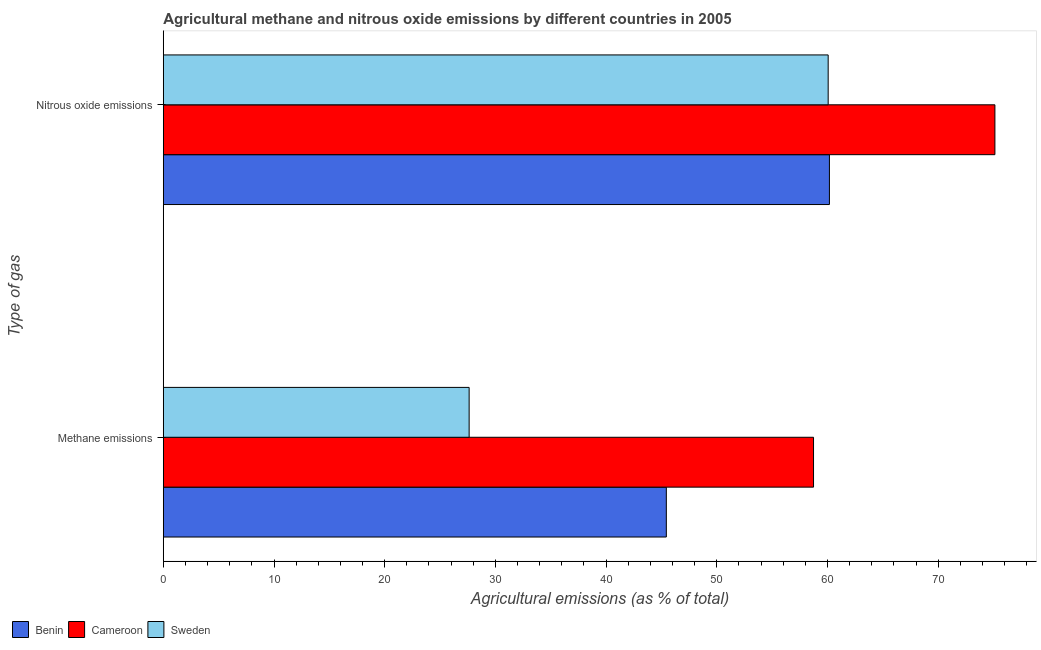How many groups of bars are there?
Provide a succinct answer. 2. How many bars are there on the 2nd tick from the bottom?
Provide a short and direct response. 3. What is the label of the 2nd group of bars from the top?
Offer a terse response. Methane emissions. What is the amount of methane emissions in Sweden?
Provide a succinct answer. 27.63. Across all countries, what is the maximum amount of methane emissions?
Offer a very short reply. 58.74. Across all countries, what is the minimum amount of methane emissions?
Keep it short and to the point. 27.63. In which country was the amount of nitrous oxide emissions maximum?
Make the answer very short. Cameroon. In which country was the amount of methane emissions minimum?
Give a very brief answer. Sweden. What is the total amount of nitrous oxide emissions in the graph?
Keep it short and to the point. 195.37. What is the difference between the amount of nitrous oxide emissions in Cameroon and that in Benin?
Your answer should be compact. 14.95. What is the difference between the amount of nitrous oxide emissions in Benin and the amount of methane emissions in Cameroon?
Give a very brief answer. 1.44. What is the average amount of nitrous oxide emissions per country?
Ensure brevity in your answer.  65.12. What is the difference between the amount of nitrous oxide emissions and amount of methane emissions in Benin?
Provide a succinct answer. 14.73. In how many countries, is the amount of methane emissions greater than 42 %?
Your response must be concise. 2. What is the ratio of the amount of nitrous oxide emissions in Cameroon to that in Benin?
Offer a terse response. 1.25. What does the 3rd bar from the top in Nitrous oxide emissions represents?
Ensure brevity in your answer.  Benin. What does the 1st bar from the bottom in Nitrous oxide emissions represents?
Provide a succinct answer. Benin. Are all the bars in the graph horizontal?
Your response must be concise. Yes. How many countries are there in the graph?
Your answer should be very brief. 3. What is the difference between two consecutive major ticks on the X-axis?
Offer a very short reply. 10. Does the graph contain any zero values?
Provide a succinct answer. No. Where does the legend appear in the graph?
Your answer should be very brief. Bottom left. How many legend labels are there?
Keep it short and to the point. 3. What is the title of the graph?
Your answer should be compact. Agricultural methane and nitrous oxide emissions by different countries in 2005. Does "Timor-Leste" appear as one of the legend labels in the graph?
Provide a succinct answer. No. What is the label or title of the X-axis?
Make the answer very short. Agricultural emissions (as % of total). What is the label or title of the Y-axis?
Ensure brevity in your answer.  Type of gas. What is the Agricultural emissions (as % of total) of Benin in Methane emissions?
Make the answer very short. 45.44. What is the Agricultural emissions (as % of total) in Cameroon in Methane emissions?
Offer a very short reply. 58.74. What is the Agricultural emissions (as % of total) in Sweden in Methane emissions?
Offer a very short reply. 27.63. What is the Agricultural emissions (as % of total) in Benin in Nitrous oxide emissions?
Provide a succinct answer. 60.18. What is the Agricultural emissions (as % of total) of Cameroon in Nitrous oxide emissions?
Provide a succinct answer. 75.13. What is the Agricultural emissions (as % of total) of Sweden in Nitrous oxide emissions?
Your answer should be compact. 60.06. Across all Type of gas, what is the maximum Agricultural emissions (as % of total) in Benin?
Keep it short and to the point. 60.18. Across all Type of gas, what is the maximum Agricultural emissions (as % of total) of Cameroon?
Offer a terse response. 75.13. Across all Type of gas, what is the maximum Agricultural emissions (as % of total) of Sweden?
Make the answer very short. 60.06. Across all Type of gas, what is the minimum Agricultural emissions (as % of total) of Benin?
Your answer should be compact. 45.44. Across all Type of gas, what is the minimum Agricultural emissions (as % of total) in Cameroon?
Make the answer very short. 58.74. Across all Type of gas, what is the minimum Agricultural emissions (as % of total) in Sweden?
Make the answer very short. 27.63. What is the total Agricultural emissions (as % of total) in Benin in the graph?
Give a very brief answer. 105.62. What is the total Agricultural emissions (as % of total) in Cameroon in the graph?
Make the answer very short. 133.87. What is the total Agricultural emissions (as % of total) of Sweden in the graph?
Your answer should be very brief. 87.69. What is the difference between the Agricultural emissions (as % of total) in Benin in Methane emissions and that in Nitrous oxide emissions?
Your answer should be compact. -14.73. What is the difference between the Agricultural emissions (as % of total) of Cameroon in Methane emissions and that in Nitrous oxide emissions?
Provide a succinct answer. -16.39. What is the difference between the Agricultural emissions (as % of total) in Sweden in Methane emissions and that in Nitrous oxide emissions?
Make the answer very short. -32.44. What is the difference between the Agricultural emissions (as % of total) in Benin in Methane emissions and the Agricultural emissions (as % of total) in Cameroon in Nitrous oxide emissions?
Your response must be concise. -29.68. What is the difference between the Agricultural emissions (as % of total) in Benin in Methane emissions and the Agricultural emissions (as % of total) in Sweden in Nitrous oxide emissions?
Your answer should be compact. -14.62. What is the difference between the Agricultural emissions (as % of total) of Cameroon in Methane emissions and the Agricultural emissions (as % of total) of Sweden in Nitrous oxide emissions?
Provide a succinct answer. -1.32. What is the average Agricultural emissions (as % of total) of Benin per Type of gas?
Provide a short and direct response. 52.81. What is the average Agricultural emissions (as % of total) of Cameroon per Type of gas?
Your response must be concise. 66.93. What is the average Agricultural emissions (as % of total) in Sweden per Type of gas?
Your response must be concise. 43.85. What is the difference between the Agricultural emissions (as % of total) of Benin and Agricultural emissions (as % of total) of Cameroon in Methane emissions?
Offer a very short reply. -13.3. What is the difference between the Agricultural emissions (as % of total) in Benin and Agricultural emissions (as % of total) in Sweden in Methane emissions?
Your response must be concise. 17.81. What is the difference between the Agricultural emissions (as % of total) of Cameroon and Agricultural emissions (as % of total) of Sweden in Methane emissions?
Your response must be concise. 31.11. What is the difference between the Agricultural emissions (as % of total) in Benin and Agricultural emissions (as % of total) in Cameroon in Nitrous oxide emissions?
Your response must be concise. -14.95. What is the difference between the Agricultural emissions (as % of total) in Benin and Agricultural emissions (as % of total) in Sweden in Nitrous oxide emissions?
Offer a very short reply. 0.11. What is the difference between the Agricultural emissions (as % of total) of Cameroon and Agricultural emissions (as % of total) of Sweden in Nitrous oxide emissions?
Give a very brief answer. 15.06. What is the ratio of the Agricultural emissions (as % of total) of Benin in Methane emissions to that in Nitrous oxide emissions?
Offer a very short reply. 0.76. What is the ratio of the Agricultural emissions (as % of total) in Cameroon in Methane emissions to that in Nitrous oxide emissions?
Give a very brief answer. 0.78. What is the ratio of the Agricultural emissions (as % of total) of Sweden in Methane emissions to that in Nitrous oxide emissions?
Make the answer very short. 0.46. What is the difference between the highest and the second highest Agricultural emissions (as % of total) in Benin?
Offer a terse response. 14.73. What is the difference between the highest and the second highest Agricultural emissions (as % of total) of Cameroon?
Make the answer very short. 16.39. What is the difference between the highest and the second highest Agricultural emissions (as % of total) of Sweden?
Your answer should be very brief. 32.44. What is the difference between the highest and the lowest Agricultural emissions (as % of total) in Benin?
Make the answer very short. 14.73. What is the difference between the highest and the lowest Agricultural emissions (as % of total) of Cameroon?
Make the answer very short. 16.39. What is the difference between the highest and the lowest Agricultural emissions (as % of total) in Sweden?
Keep it short and to the point. 32.44. 